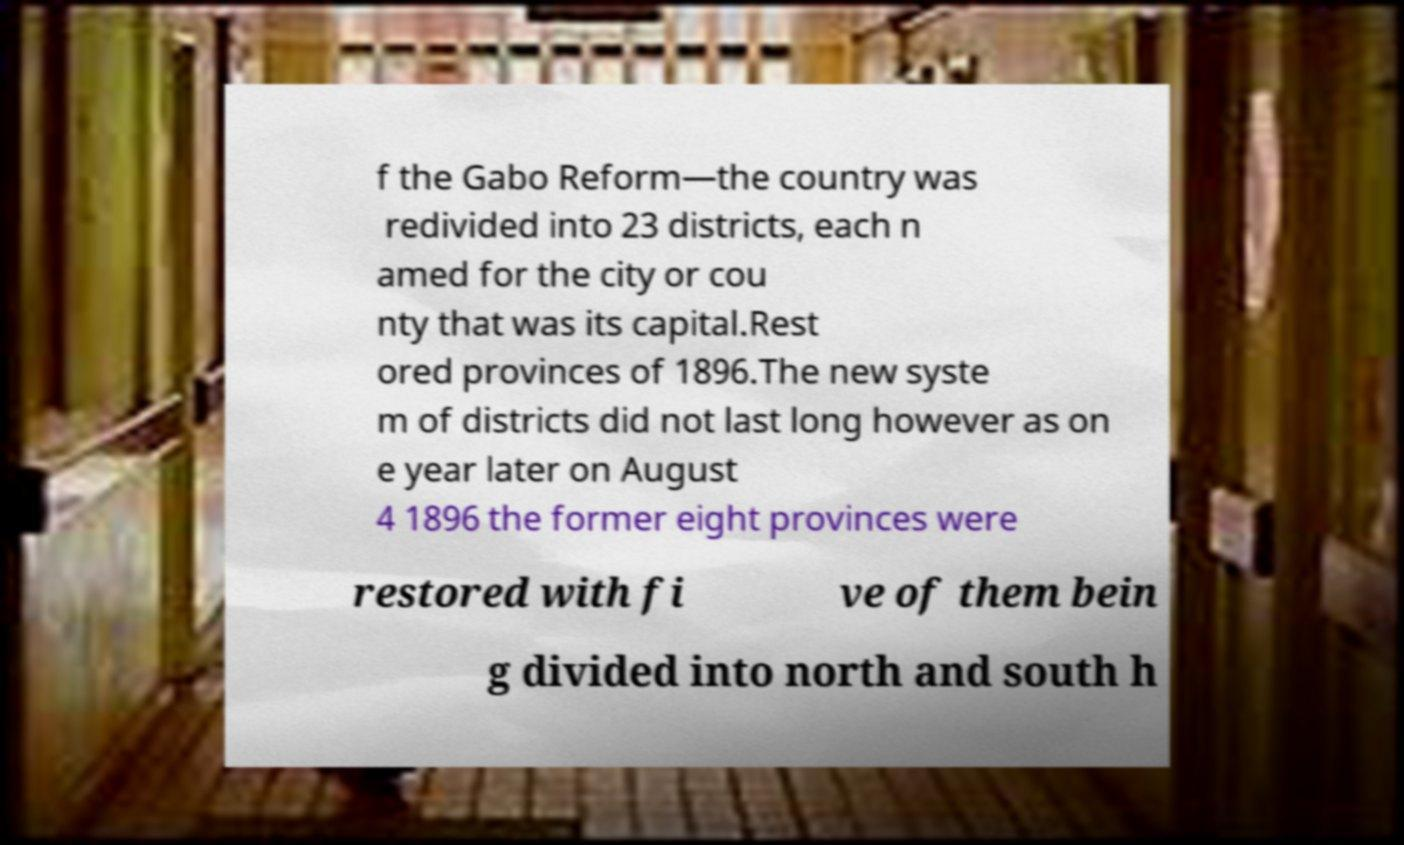Could you extract and type out the text from this image? f the Gabo Reform—the country was redivided into 23 districts, each n amed for the city or cou nty that was its capital.Rest ored provinces of 1896.The new syste m of districts did not last long however as on e year later on August 4 1896 the former eight provinces were restored with fi ve of them bein g divided into north and south h 